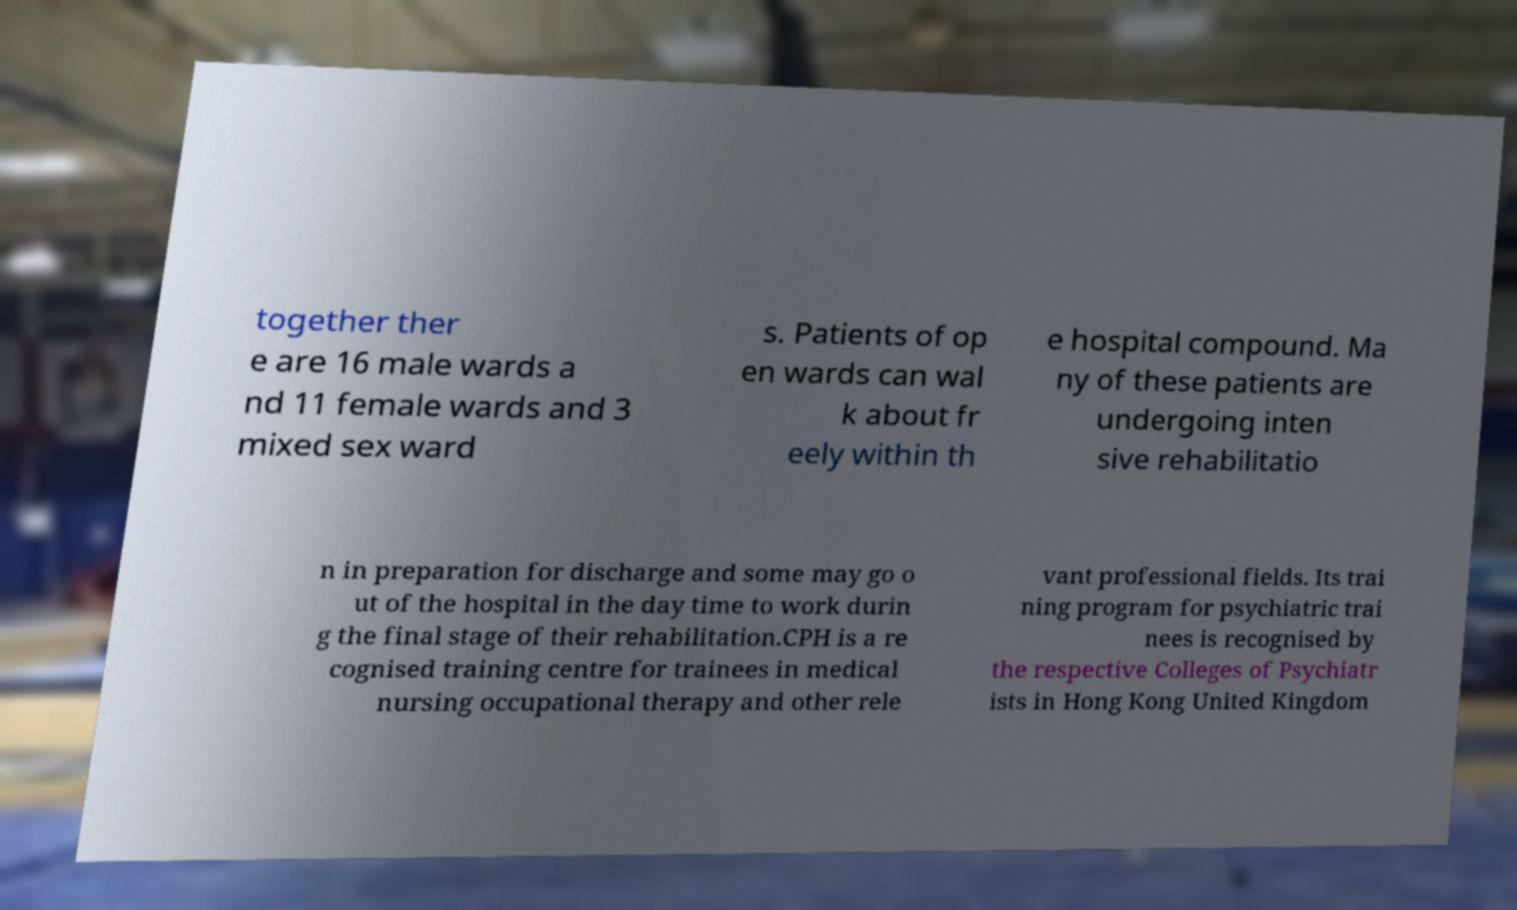Can you read and provide the text displayed in the image?This photo seems to have some interesting text. Can you extract and type it out for me? together ther e are 16 male wards a nd 11 female wards and 3 mixed sex ward s. Patients of op en wards can wal k about fr eely within th e hospital compound. Ma ny of these patients are undergoing inten sive rehabilitatio n in preparation for discharge and some may go o ut of the hospital in the day time to work durin g the final stage of their rehabilitation.CPH is a re cognised training centre for trainees in medical nursing occupational therapy and other rele vant professional fields. Its trai ning program for psychiatric trai nees is recognised by the respective Colleges of Psychiatr ists in Hong Kong United Kingdom 